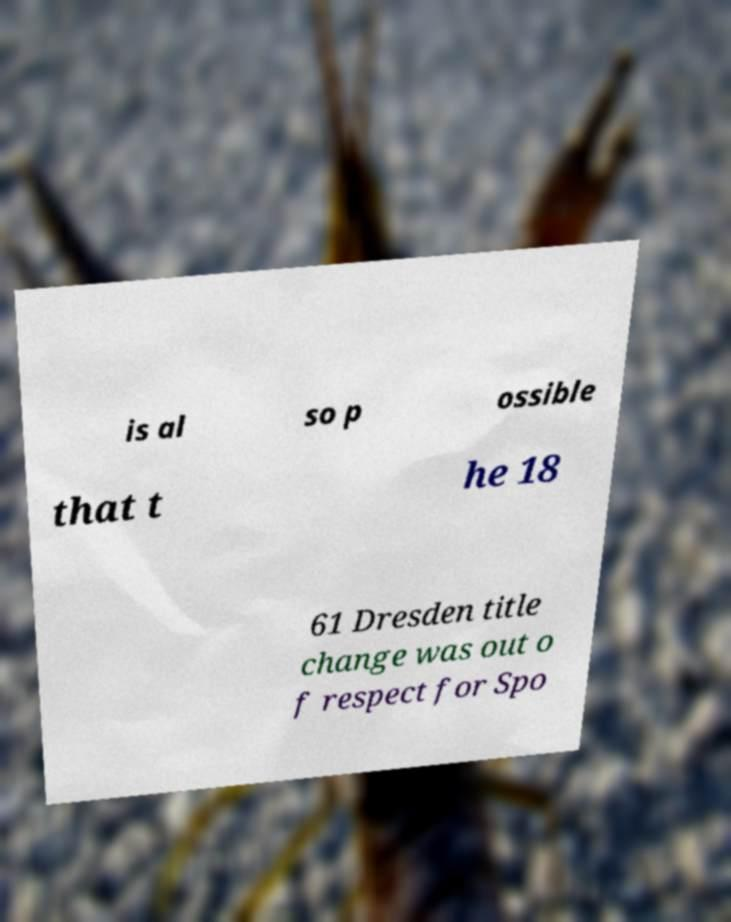Can you read and provide the text displayed in the image?This photo seems to have some interesting text. Can you extract and type it out for me? is al so p ossible that t he 18 61 Dresden title change was out o f respect for Spo 